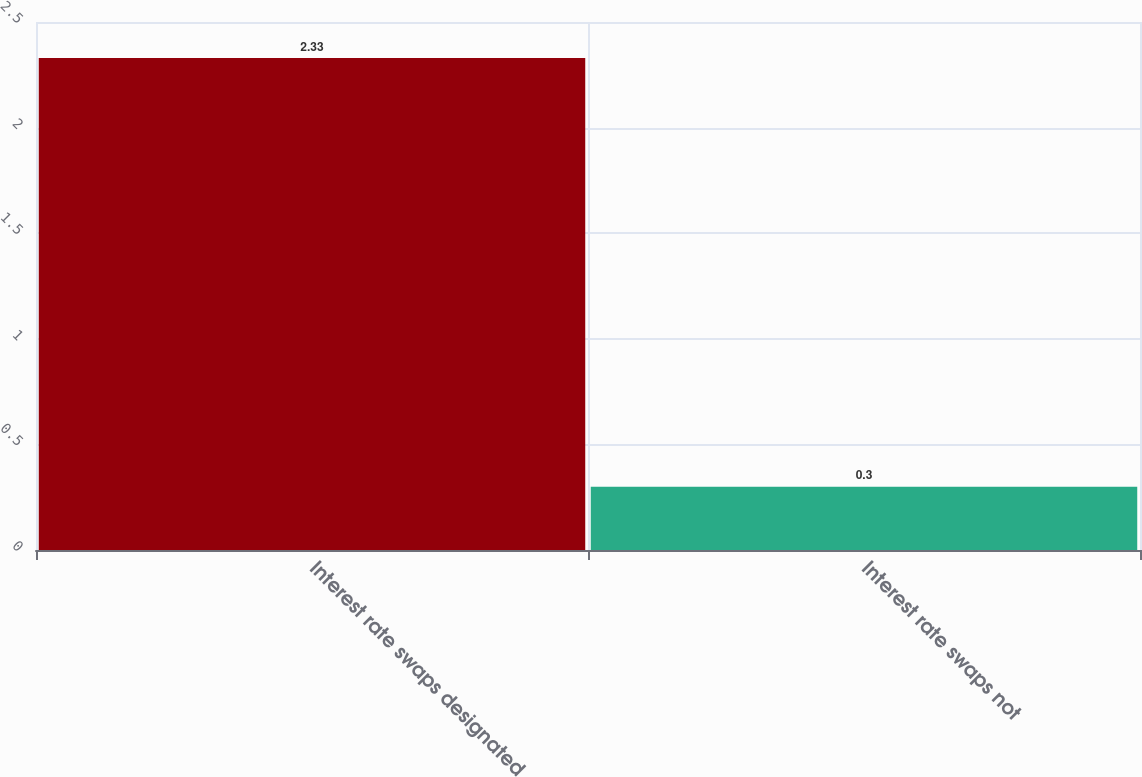Convert chart to OTSL. <chart><loc_0><loc_0><loc_500><loc_500><bar_chart><fcel>Interest rate swaps designated<fcel>Interest rate swaps not<nl><fcel>2.33<fcel>0.3<nl></chart> 